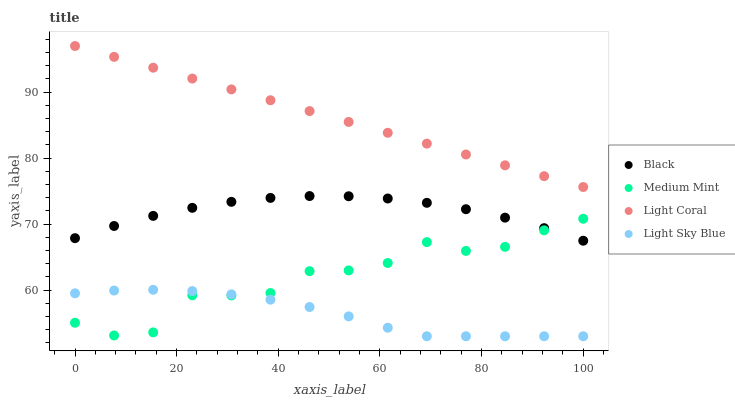Does Light Sky Blue have the minimum area under the curve?
Answer yes or no. Yes. Does Light Coral have the maximum area under the curve?
Answer yes or no. Yes. Does Light Coral have the minimum area under the curve?
Answer yes or no. No. Does Light Sky Blue have the maximum area under the curve?
Answer yes or no. No. Is Light Coral the smoothest?
Answer yes or no. Yes. Is Medium Mint the roughest?
Answer yes or no. Yes. Is Light Sky Blue the smoothest?
Answer yes or no. No. Is Light Sky Blue the roughest?
Answer yes or no. No. Does Light Sky Blue have the lowest value?
Answer yes or no. Yes. Does Light Coral have the lowest value?
Answer yes or no. No. Does Light Coral have the highest value?
Answer yes or no. Yes. Does Light Sky Blue have the highest value?
Answer yes or no. No. Is Light Sky Blue less than Black?
Answer yes or no. Yes. Is Light Coral greater than Light Sky Blue?
Answer yes or no. Yes. Does Black intersect Medium Mint?
Answer yes or no. Yes. Is Black less than Medium Mint?
Answer yes or no. No. Is Black greater than Medium Mint?
Answer yes or no. No. Does Light Sky Blue intersect Black?
Answer yes or no. No. 